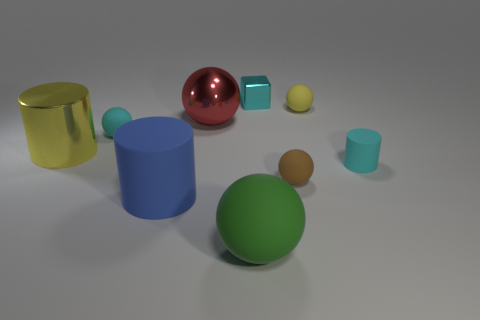Is there any object in a higher position than the green sphere, and if so, what is its color? No, the green sphere is positioned at the lowest point within the frame of the image, resting directly on the surface. All other objects are resting on the same level and none appear elevated above the green sphere. 